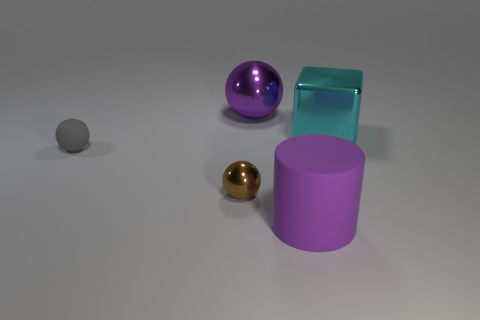Can you describe the textures of the objects shown? Certainly! The large purple cylinder appears to have a matte texture, absorbing light rather than reflecting it. The smaller sphere next to it has a mirrored surface, reflecting its surroundings. The larger sphere has a shiny finish but is slightly less reflective than the gold sphere, indicating a smoother texture, and the tall object resembles glass, with a semi-transparent, glossy appearance. 